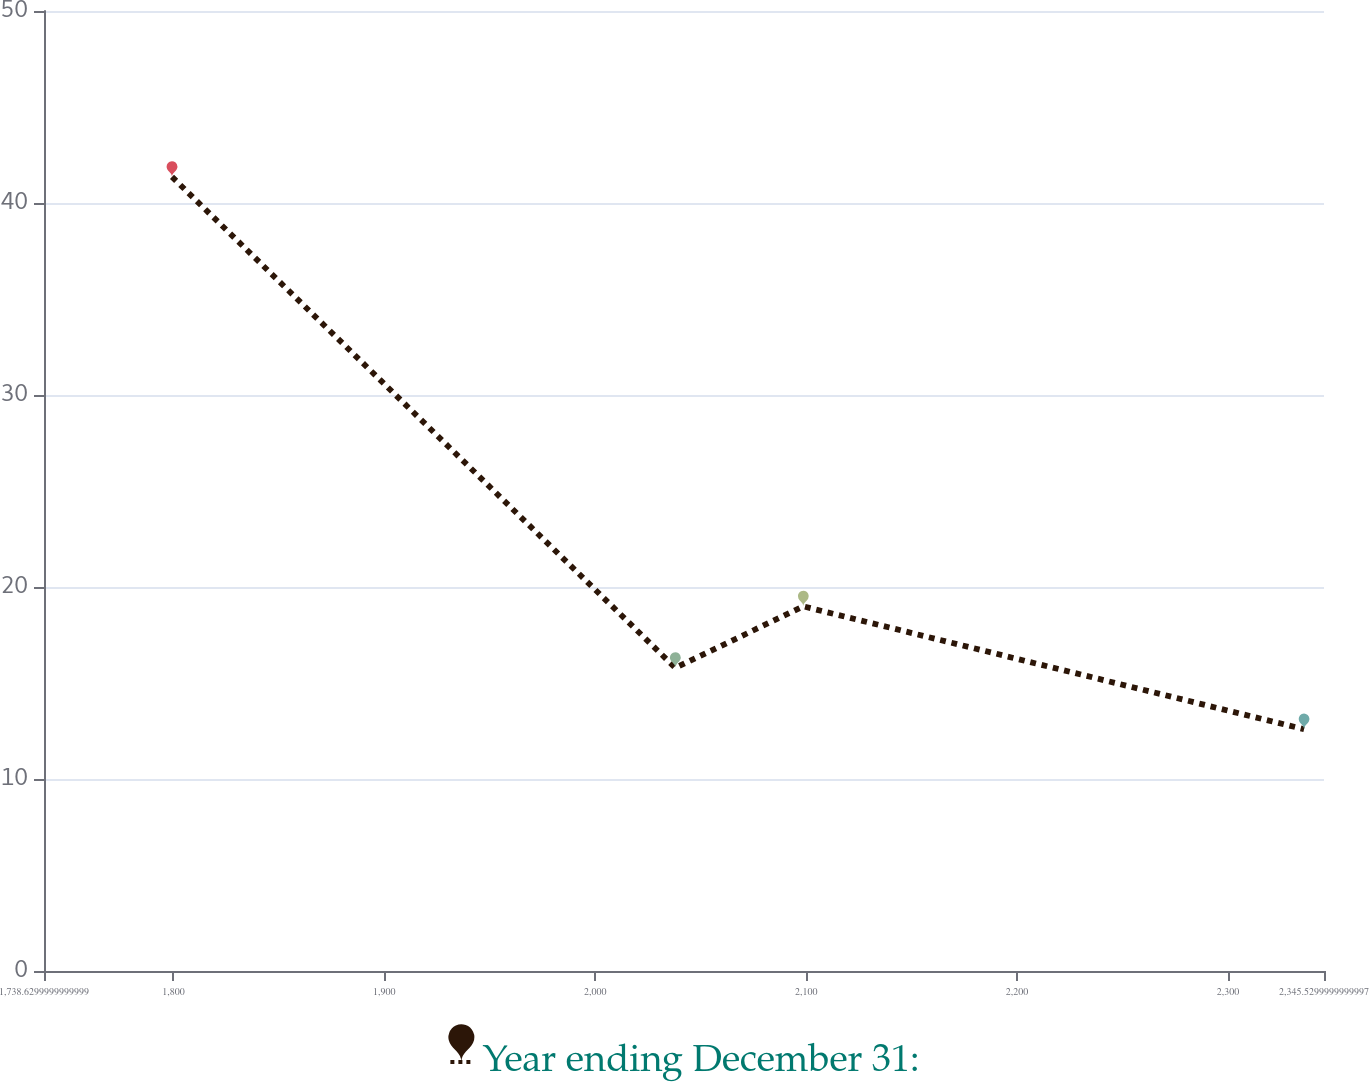<chart> <loc_0><loc_0><loc_500><loc_500><line_chart><ecel><fcel>Year ending December 31:<nl><fcel>1799.32<fcel>41.36<nl><fcel>2037.96<fcel>15.79<nl><fcel>2098.65<fcel>18.99<nl><fcel>2336.08<fcel>12.59<nl><fcel>2406.22<fcel>9.39<nl></chart> 